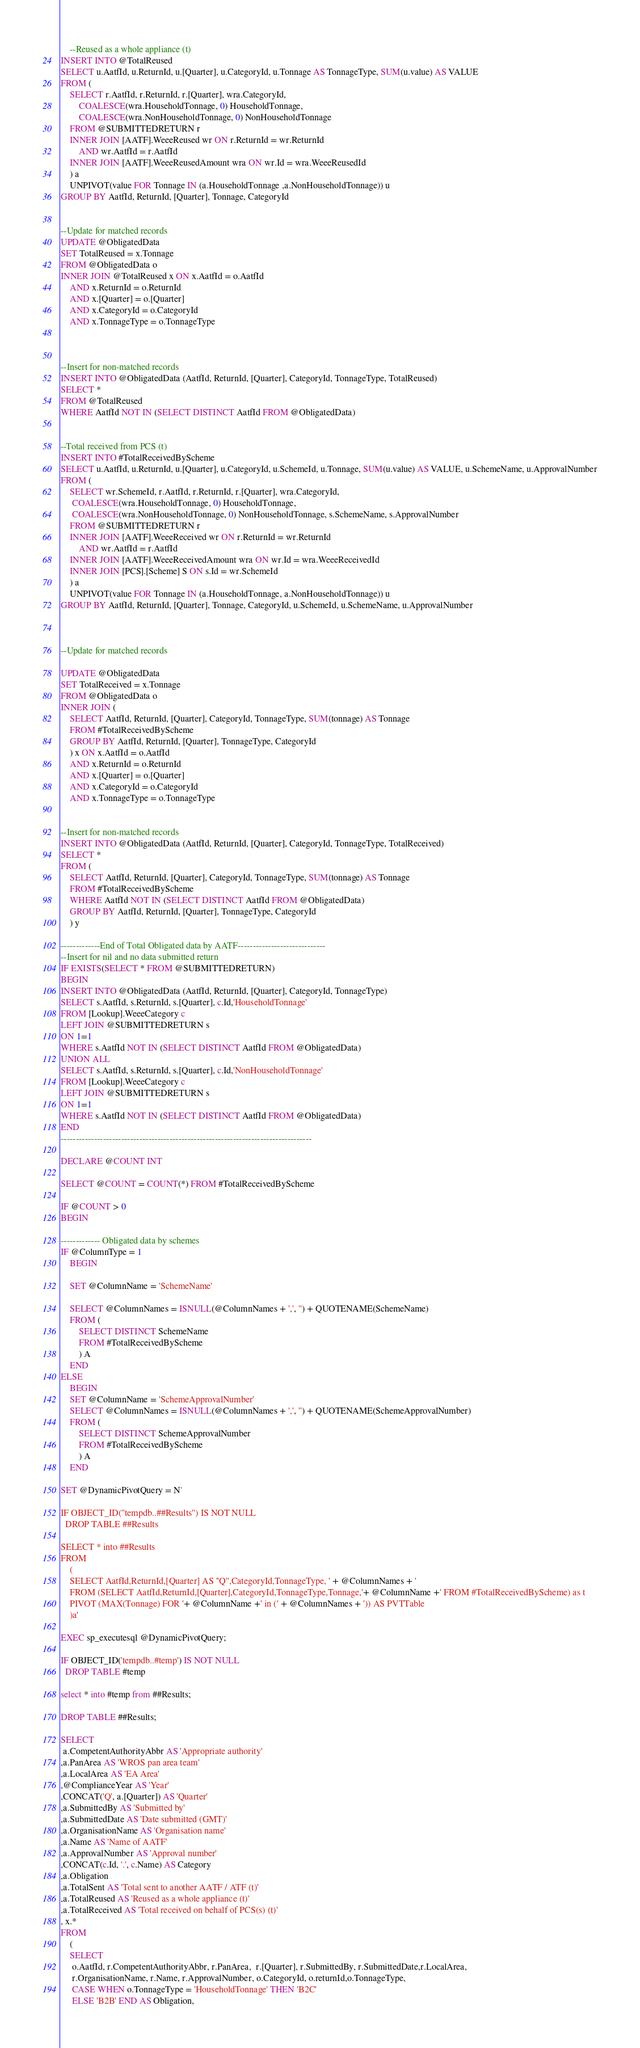<code> <loc_0><loc_0><loc_500><loc_500><_SQL_>	--Reused as a whole appliance (t)
INSERT INTO @TotalReused
SELECT u.AatfId, u.ReturnId, u.[Quarter], u.CategoryId, u.Tonnage AS TonnageType, SUM(u.value) AS VALUE
FROM (
	SELECT r.AatfId, r.ReturnId, r.[Quarter], wra.CategoryId, 
		COALESCE(wra.HouseholdTonnage, 0) HouseholdTonnage,
		COALESCE(wra.NonHouseholdTonnage, 0) NonHouseholdTonnage
	FROM @SUBMITTEDRETURN r
	INNER JOIN [AATF].WeeeReused wr ON r.ReturnId = wr.ReturnId
		AND wr.AatfId = r.AatfId
	INNER JOIN [AATF].WeeeReusedAmount wra ON wr.Id = wra.WeeeReusedId
	) a
	UNPIVOT(value FOR Tonnage IN (a.HouseholdTonnage ,a.NonHouseholdTonnage)) u
GROUP BY AatfId, ReturnId, [Quarter], Tonnage, CategoryId


--Update for matched records
UPDATE @ObligatedData
SET TotalReused = x.Tonnage
FROM @ObligatedData o
INNER JOIN @TotalReused x ON x.AatfId = o.AatfId
	AND x.ReturnId = o.ReturnId
	AND x.[Quarter] = o.[Quarter]
	AND x.CategoryId = o.CategoryId
	AND x.TonnageType = o.TonnageType



--Insert for non-matched records
INSERT INTO @ObligatedData (AatfId, ReturnId, [Quarter], CategoryId, TonnageType, TotalReused)
SELECT *
FROM @TotalReused
WHERE AatfId NOT IN (SELECT DISTINCT AatfId FROM @ObligatedData)


--Total received from PCS (t)
INSERT INTO #TotalReceivedByScheme
SELECT u.AatfId, u.ReturnId, u.[Quarter], u.CategoryId, u.SchemeId, u.Tonnage, SUM(u.value) AS VALUE, u.SchemeName, u.ApprovalNumber
FROM (
	SELECT wr.SchemeId, r.AatfId, r.ReturnId, r.[Quarter], wra.CategoryId,
	 COALESCE(wra.HouseholdTonnage, 0) HouseholdTonnage,
	 COALESCE(wra.NonHouseholdTonnage, 0) NonHouseholdTonnage, s.SchemeName, s.ApprovalNumber
	FROM @SUBMITTEDRETURN r
	INNER JOIN [AATF].WeeeReceived wr ON r.ReturnId = wr.ReturnId
		AND wr.AatfId = r.AatfId
	INNER JOIN [AATF].WeeeReceivedAmount wra ON wr.Id = wra.WeeeReceivedId
	INNER JOIN [PCS].[Scheme] S ON s.Id = wr.SchemeId
	) a
	UNPIVOT(value FOR Tonnage IN (a.HouseholdTonnage, a.NonHouseholdTonnage)) u
GROUP BY AatfId, ReturnId, [Quarter], Tonnage, CategoryId, u.SchemeId, u.SchemeName, u.ApprovalNumber



--Update for matched records

UPDATE @ObligatedData
SET TotalReceived = x.Tonnage
FROM @ObligatedData o
INNER JOIN (
	SELECT AatfId, ReturnId, [Quarter], CategoryId, TonnageType, SUM(tonnage) AS Tonnage
	FROM #TotalReceivedByScheme
	GROUP BY AatfId, ReturnId, [Quarter], TonnageType, CategoryId
	) x ON x.AatfId = o.AatfId
	AND x.ReturnId = o.ReturnId
	AND x.[Quarter] = o.[Quarter]
	AND x.CategoryId = o.CategoryId
	AND x.TonnageType = o.TonnageType


--Insert for non-matched records
INSERT INTO @ObligatedData (AatfId, ReturnId, [Quarter], CategoryId, TonnageType, TotalReceived)
SELECT *
FROM (
	SELECT AatfId, ReturnId, [Quarter], CategoryId, TonnageType, SUM(tonnage) AS Tonnage
	FROM #TotalReceivedByScheme
	WHERE AatfId NOT IN (SELECT DISTINCT AatfId FROM @ObligatedData)
	GROUP BY AatfId, ReturnId, [Quarter], TonnageType, CategoryId
	) y

-------------End of Total Obligated data by AATF-----------------------------
--Insert for nil and no data submitted return
IF EXISTS(SELECT * FROM @SUBMITTEDRETURN) 
BEGIN
INSERT INTO @ObligatedData (AatfId, ReturnId, [Quarter], CategoryId, TonnageType)
SELECT s.AatfId, s.ReturnId, s.[Quarter], c.Id,'HouseholdTonnage'
FROM [Lookup].WeeeCategory c 
LEFT JOIN @SUBMITTEDRETURN s
ON 1=1 
WHERE s.AatfId NOT IN (SELECT DISTINCT AatfId FROM @ObligatedData)
UNION ALL
SELECT s.AatfId, s.ReturnId, s.[Quarter], c.Id,'NonHouseholdTonnage'
FROM [Lookup].WeeeCategory c 
LEFT JOIN @SUBMITTEDRETURN s
ON 1=1 
WHERE s.AatfId NOT IN (SELECT DISTINCT AatfId FROM @ObligatedData)
END
-----------------------------------------------------------------------------------

DECLARE @COUNT INT

SELECT @COUNT = COUNT(*) FROM #TotalReceivedByScheme

IF @COUNT > 0
BEGIN

------------- Obligated data by schemes
IF @ColumnType = 1
	BEGIN

	SET @ColumnName = 'SchemeName'

	SELECT @ColumnNames = ISNULL(@ColumnNames + ',', '') + QUOTENAME(SchemeName)
	FROM (
		SELECT DISTINCT SchemeName
		FROM #TotalReceivedByScheme
		) A
	END
ELSE
	BEGIN
	SET @ColumnName = 'SchemeApprovalNumber'
	SELECT @ColumnNames = ISNULL(@ColumnNames + ',', '') + QUOTENAME(SchemeApprovalNumber)
	FROM (
		SELECT DISTINCT SchemeApprovalNumber
		FROM #TotalReceivedByScheme
		) A
	END

SET @DynamicPivotQuery = N'

IF OBJECT_ID(''tempdb..##Results'') IS NOT NULL
  DROP TABLE ##Results

SELECT * into ##Results
FROM
	(
	SELECT AatfId,ReturnId,[Quarter] AS ''Q'',CategoryId,TonnageType, ' + @ColumnNames + '
	FROM (SELECT AatfId,ReturnId,[Quarter],CategoryId,TonnageType,Tonnage,'+ @ColumnName +' FROM #TotalReceivedByScheme) as t
	PIVOT (MAX(Tonnage) FOR '+ @ColumnName +' in (' + @ColumnNames + ')) AS PVTTable
	)a'

EXEC sp_executesql @DynamicPivotQuery; 

IF OBJECT_ID('tempdb..#temp') IS NOT NULL
  DROP TABLE #temp

select * into #temp from ##Results;

DROP TABLE ##Results;

SELECT 
 a.CompetentAuthorityAbbr AS 'Appropriate authority'
,a.PanArea AS 'WROS pan area team'
,a.LocalArea AS 'EA Area'
,@ComplianceYear AS 'Year'
,CONCAT('Q', a.[Quarter]) AS 'Quarter'
,a.SubmittedBy AS 'Submitted by'
,a.SubmittedDate AS 'Date submitted (GMT)'
,a.OrganisationName AS 'Organisation name'
,a.Name AS 'Name of AATF'
,a.ApprovalNumber AS 'Approval number'
,CONCAT(c.Id, '.', c.Name) AS Category
,a.Obligation
,a.TotalSent AS 'Total sent to another AATF / ATF (t)'
,a.TotalReused AS 'Reused as a whole appliance (t)'
,a.TotalReceived AS 'Total received on behalf of PCS(s) (t)'
, x.*
FROM
	(
	SELECT
	 o.AatfId, r.CompetentAuthorityAbbr, r.PanArea,  r.[Quarter], r.SubmittedBy, r.SubmittedDate,r.LocalArea,
	 r.OrganisationName, r.Name, r.ApprovalNumber, o.CategoryId, o.returnId,o.TonnageType,
	 CASE WHEN o.TonnageType = 'HouseholdTonnage' THEN 'B2C'
	 ELSE 'B2B' END AS Obligation,</code> 